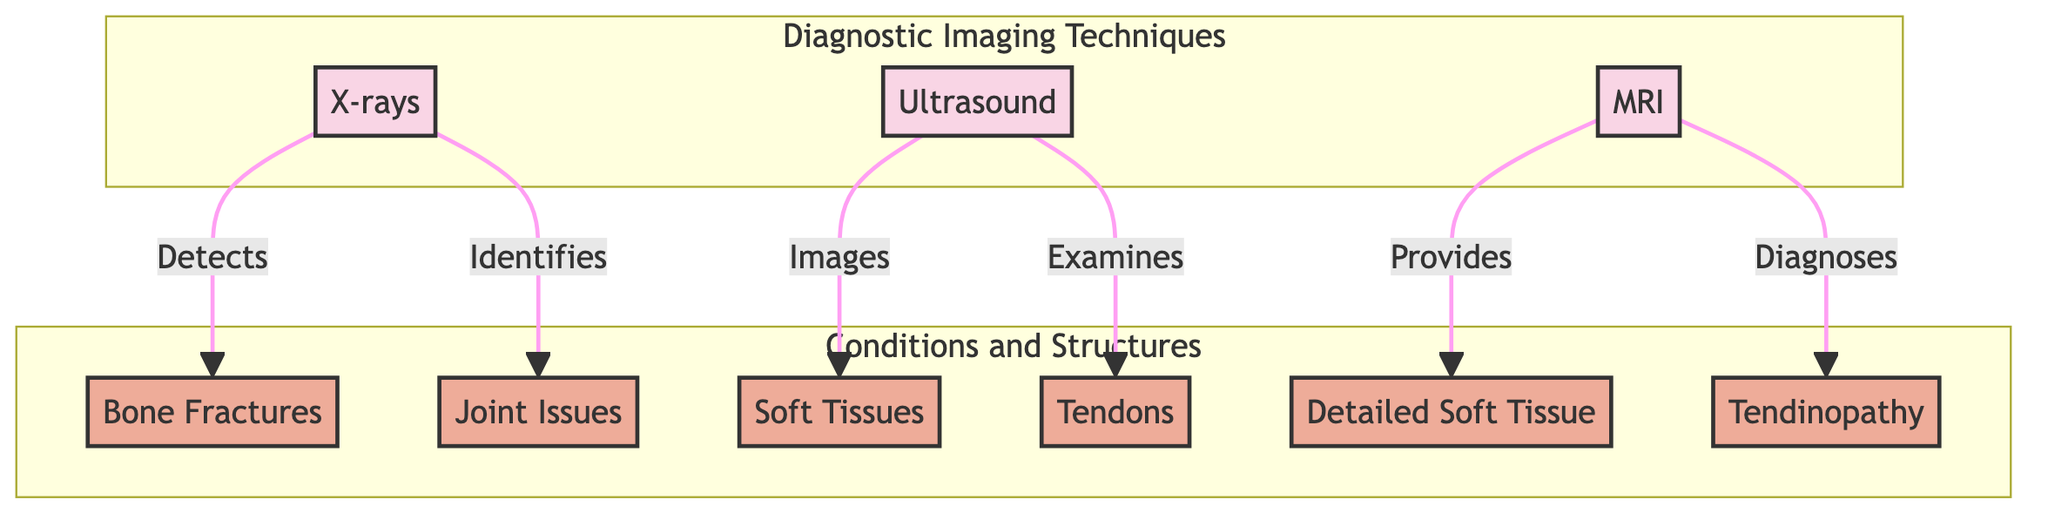What are the three diagnostic imaging techniques shown in the diagram? The diagram contains three imaging techniques labeled as X-rays, Ultrasound, and MRI.
Answer: X-rays, Ultrasound, MRI Which condition is specifically identified by X-rays? According to the diagram, X-rays detect bone fractures.
Answer: Bone Fractures How many conditions are related to Ultrasound? The diagram shows two conditions related to Ultrasound: soft tissues and tendons. Therefore, the total is two.
Answer: 2 What does MRI provide information about that is not covered by the other techniques? The diagram indicates that MRI provides detailed soft tissue images, which is not a function of X-rays or Ultrasound.
Answer: Detailed Soft Tissue Which imaging technique is used to diagnose tendinopathy? The diagram clearly shows that MRI is used to diagnose tendinopathy.
Answer: MRI What are the two conditions that are examined using Ultrasound? By reviewing the diagram, Ultrasound images soft tissues and examines tendons; these two conditions are linked directly to Ultrasound.
Answer: Soft Tissues, Tendons Which imaging technique is linked to joint issues? The diagram specifies that X-rays identify joint issues.
Answer: X-rays How many total conditions are addressed in the diagram? The diagram lists a total of six conditions: bone fractures, joint issues, soft tissues, tendons, detailed soft tissue, and tendinopathy. Therefore, the count is six.
Answer: 6 What type of relationship does X-rays have with joint issues? The diagram indicates that X-rays identify joint issues, reflecting a direct identification relationship.
Answer: Identifies 